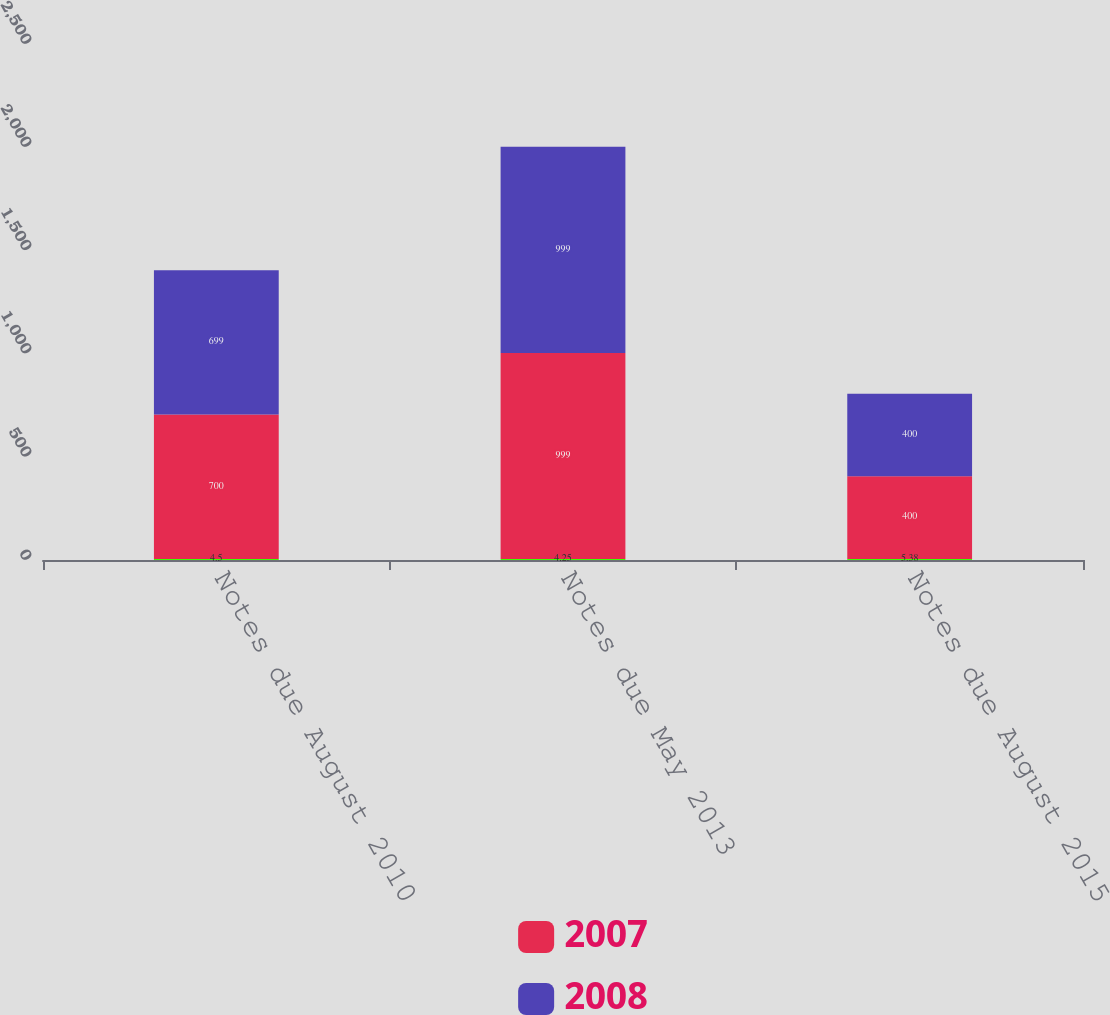Convert chart. <chart><loc_0><loc_0><loc_500><loc_500><stacked_bar_chart><ecel><fcel>Notes due August 2010<fcel>Notes due May 2013<fcel>Notes due August 2015<nl><fcel>nan<fcel>4.5<fcel>4.25<fcel>5.38<nl><fcel>2007<fcel>700<fcel>999<fcel>400<nl><fcel>2008<fcel>699<fcel>999<fcel>400<nl></chart> 